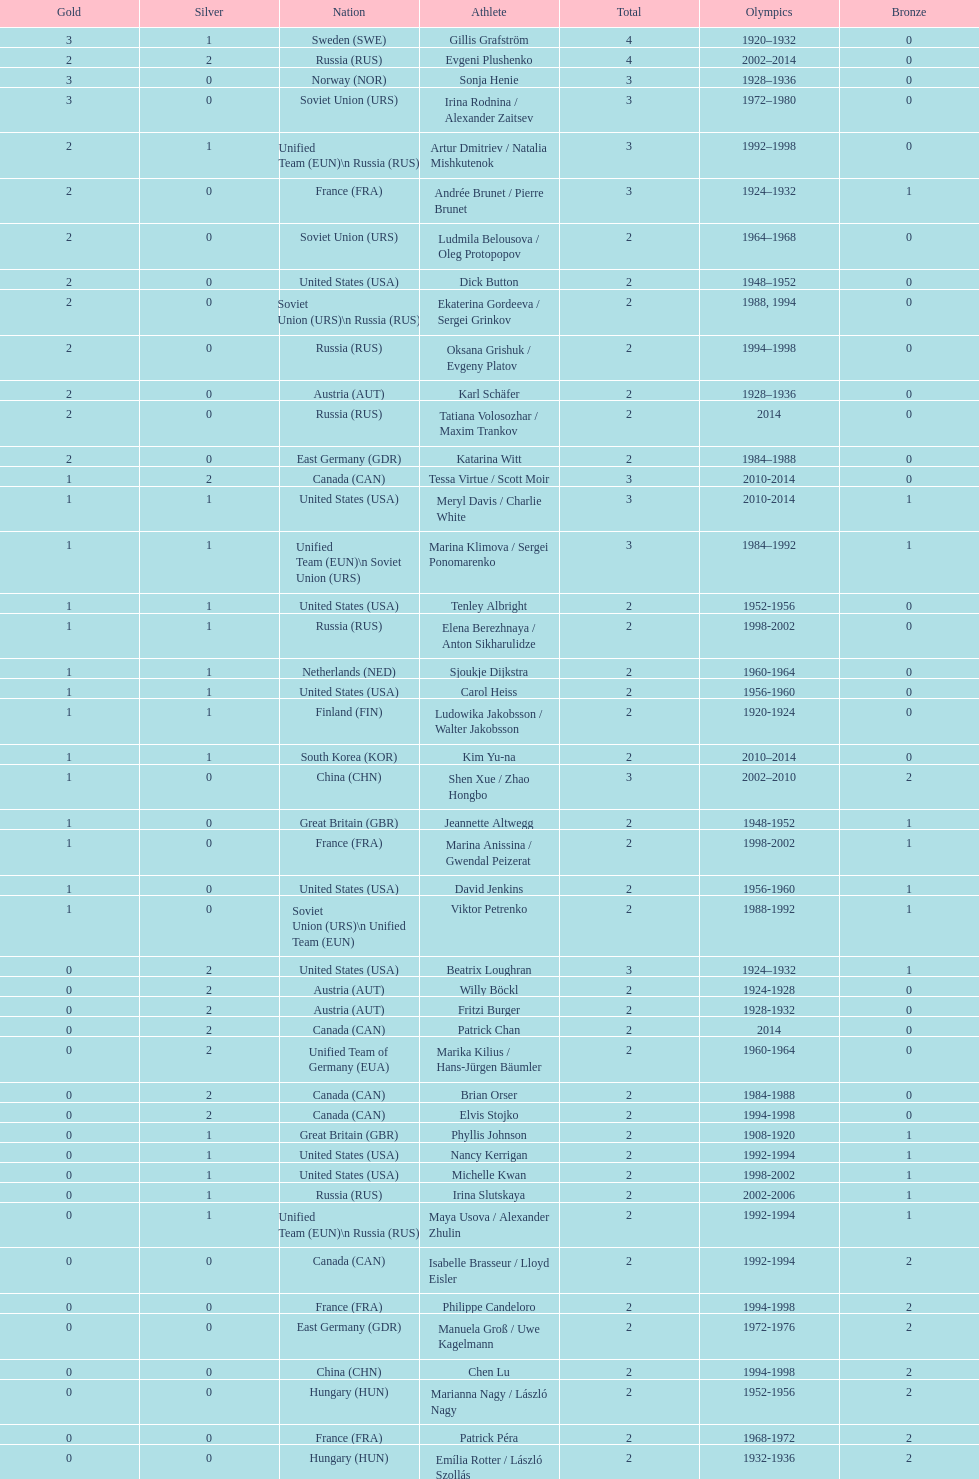Which nation was the first to win three gold medals for olympic figure skating? Sweden. 